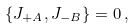Convert formula to latex. <formula><loc_0><loc_0><loc_500><loc_500>\{ J _ { + A } , J _ { - B } \} = 0 \, ,</formula> 